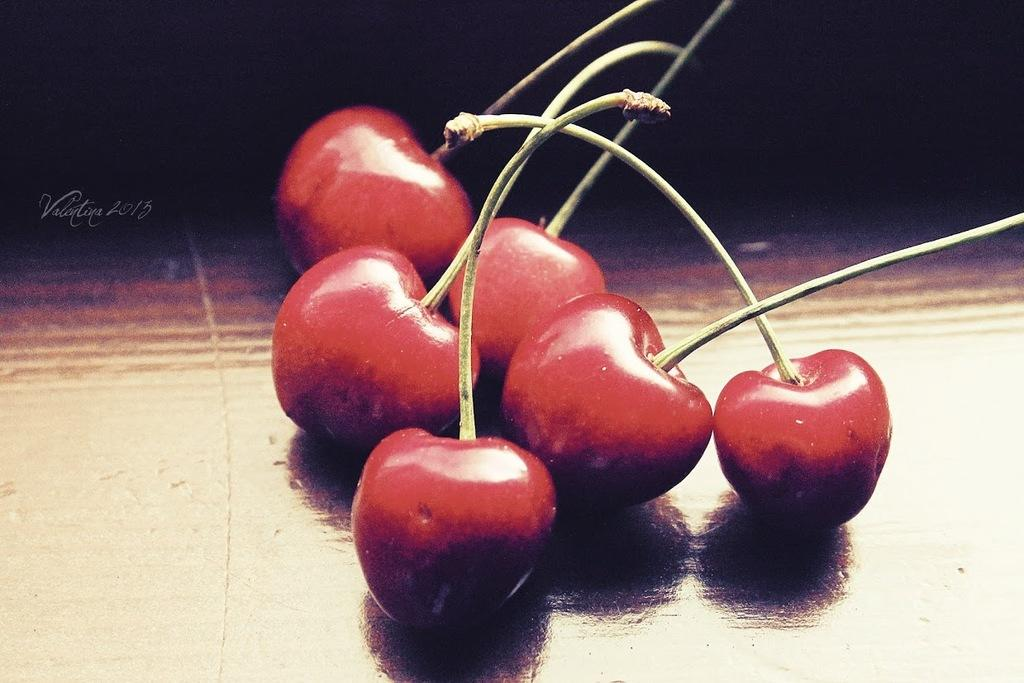What is placed on the table in the center of the image? There are cherries placed on a table in the center of the image. Can you describe the background of the image? The background of the image is dark. What type of curtain is hanging in the image? There is no curtain present in the image. What kind of test is being conducted in the image? There is no test being conducted in the image. What type of help is being offered in the image? There is no help being offered in the image. 